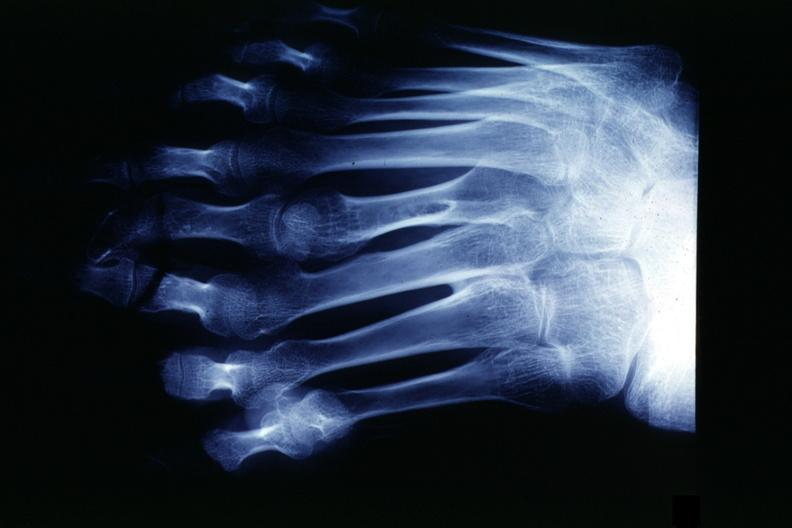re good example tastefully shown with face out of picture and genitalia present?
Answer the question using a single word or phrase. No 